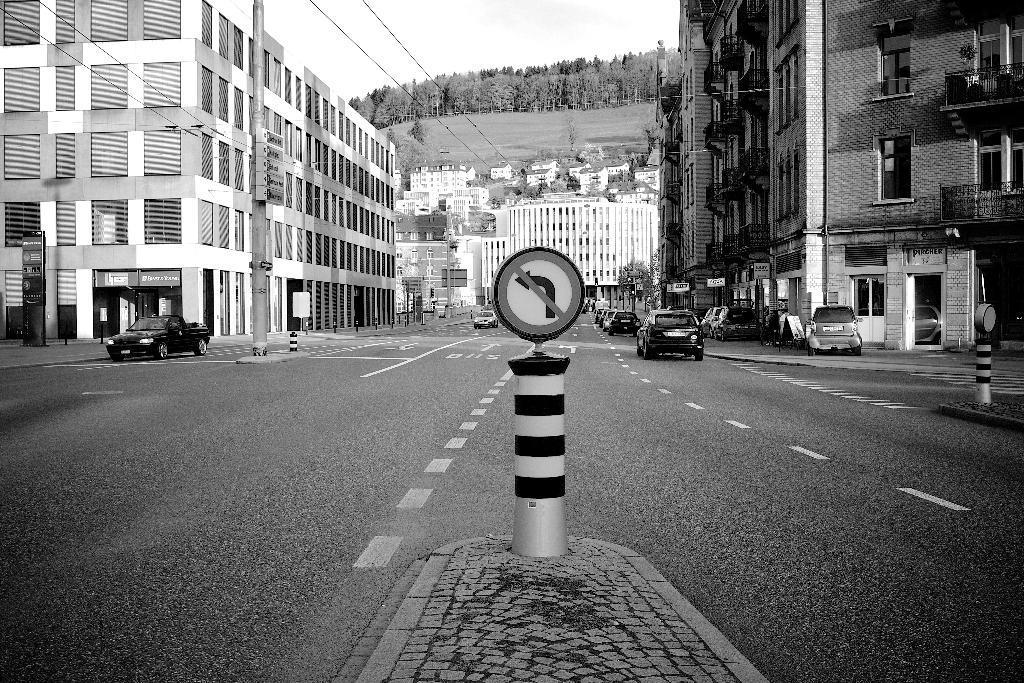In one or two sentences, can you explain what this image depicts? In this image we can see few buildings and a road between the buildings and there are few vehicles on the road, there are sign boards on the pavement, there is a current pole with board and wire and there is a board in front of the building, there are few trees and sky in the background. 